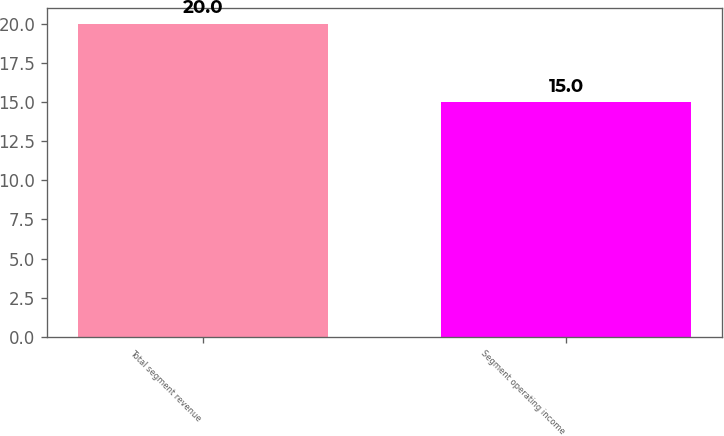<chart> <loc_0><loc_0><loc_500><loc_500><bar_chart><fcel>Total segment revenue<fcel>Segment operating income<nl><fcel>20<fcel>15<nl></chart> 